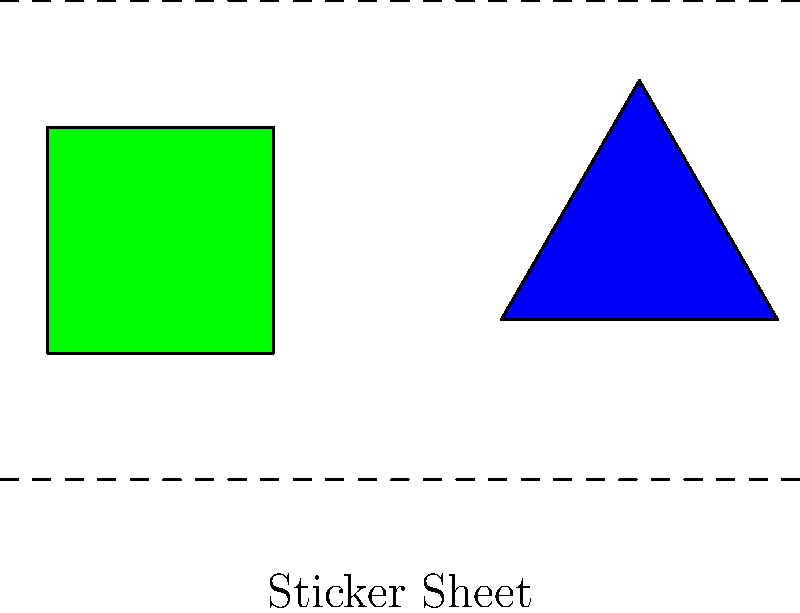Look at the sticker sheet. Can you make a symmetrical pattern by placing the square on one side and the triangle on the other side of the dashed line? Let's think about this step-by-step:

1. We have two shapes on our sticker sheet: a green square and a blue triangle.

2. The dashed lines show where we can place our stickers to make a pattern.

3. To make a symmetrical pattern, we need to place the shapes so that if we fold the paper along the dashed line, the shapes would match up perfectly.

4. If we put the square on one side of the line and the triangle on the other side, they wouldn't match up when we fold the paper.

5. The square and triangle have different shapes and sizes, so they can't create a symmetrical pattern when placed on opposite sides.

6. To make a symmetrical pattern, we would need to use the same shape on both sides of the line.
Answer: No 